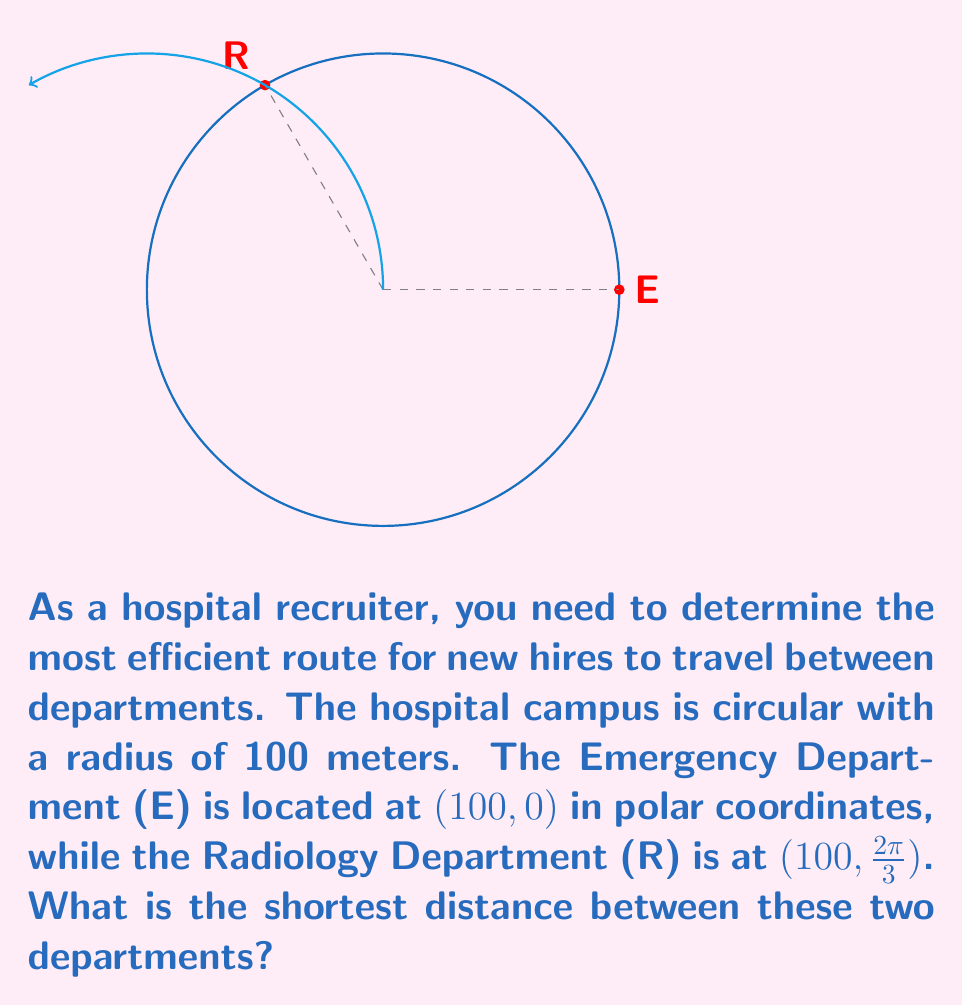Teach me how to tackle this problem. To solve this problem, we'll follow these steps:

1) In a circular layout, the shortest path between two points on the circumference is the arc length connecting them.

2) The central angle θ between the two departments can be calculated by subtracting their angular coordinates:

   $\theta = \frac{2\pi}{3} - 0 = \frac{2\pi}{3}$ radians

3) The arc length $s$ is given by the formula:

   $s = r\theta$

   where $r$ is the radius and $θ$ is the central angle in radians.

4) Substituting the values:

   $s = 100 \cdot \frac{2\pi}{3} = \frac{200\pi}{3}$ meters

5) To convert to a more practical unit, we can express this in meters:

   $\frac{200\pi}{3} \approx 209.44$ meters

Therefore, the shortest path between the Emergency Department and the Radiology Department is approximately 209.44 meters along the circular path of the hospital campus.
Answer: $\frac{200\pi}{3}$ meters or approximately 209.44 meters 